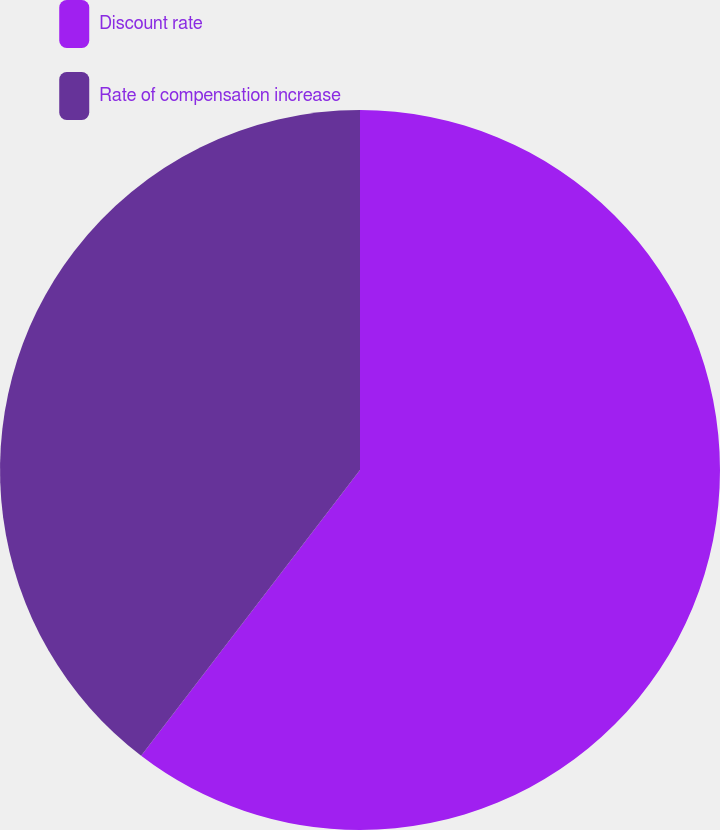<chart> <loc_0><loc_0><loc_500><loc_500><pie_chart><fcel>Discount rate<fcel>Rate of compensation increase<nl><fcel>60.4%<fcel>39.6%<nl></chart> 